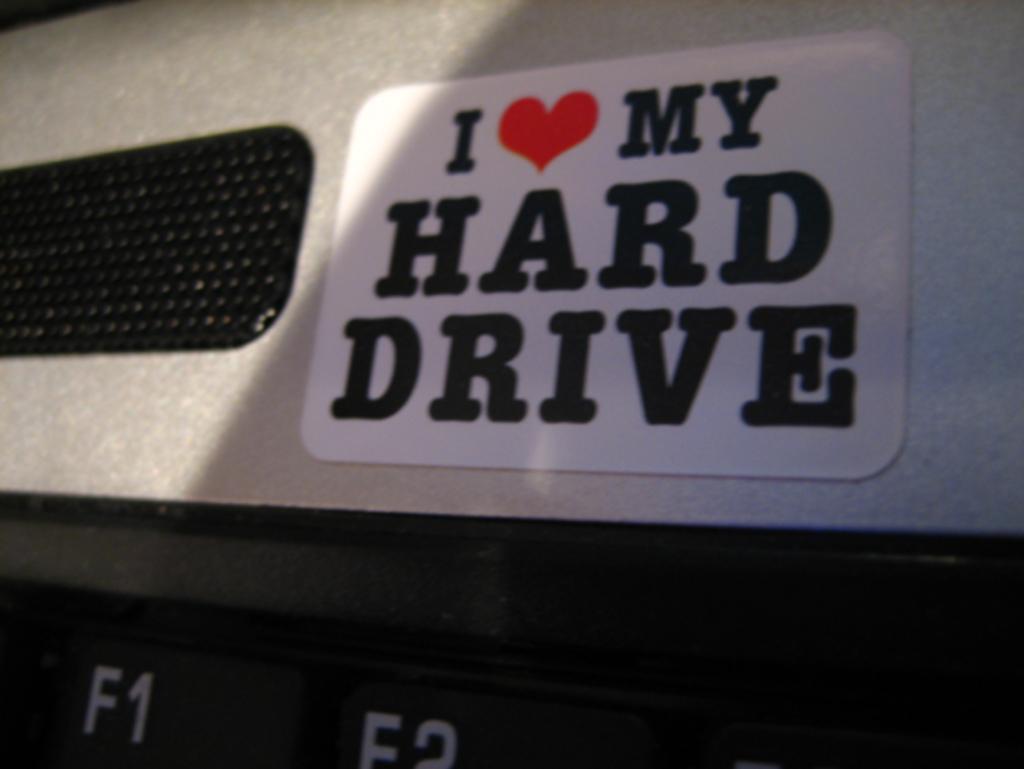Describe this image in one or two sentences. In the picture we can see a part of the laptop with a sticker on it mentioned in it as I love my hard drive. 